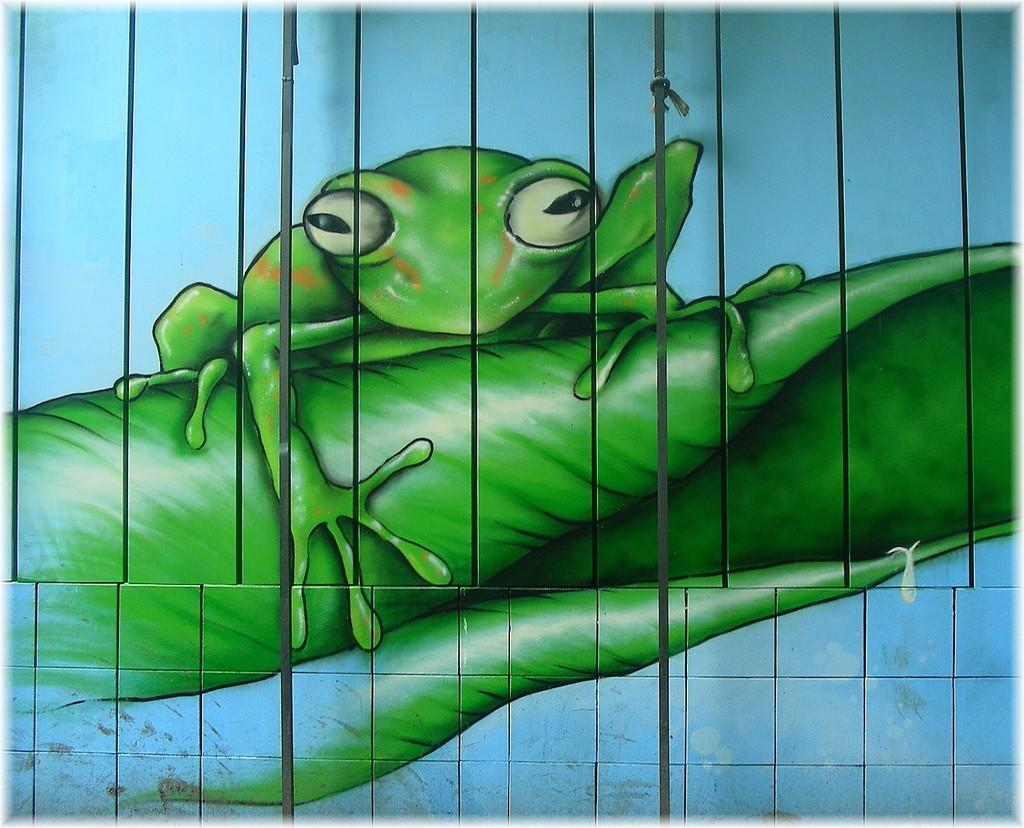What is on the wall in the image? There is a painting on the wall. What is the subject of the painting? The painting depicts a frog on a leaf. What type of property is visible in the image? There is no property visible in the image; it only features a painting of a frog on a leaf. What kind of apparel is the frog wearing in the image? The frog in the painting is not wearing any apparel; it is depicted in its natural state. 